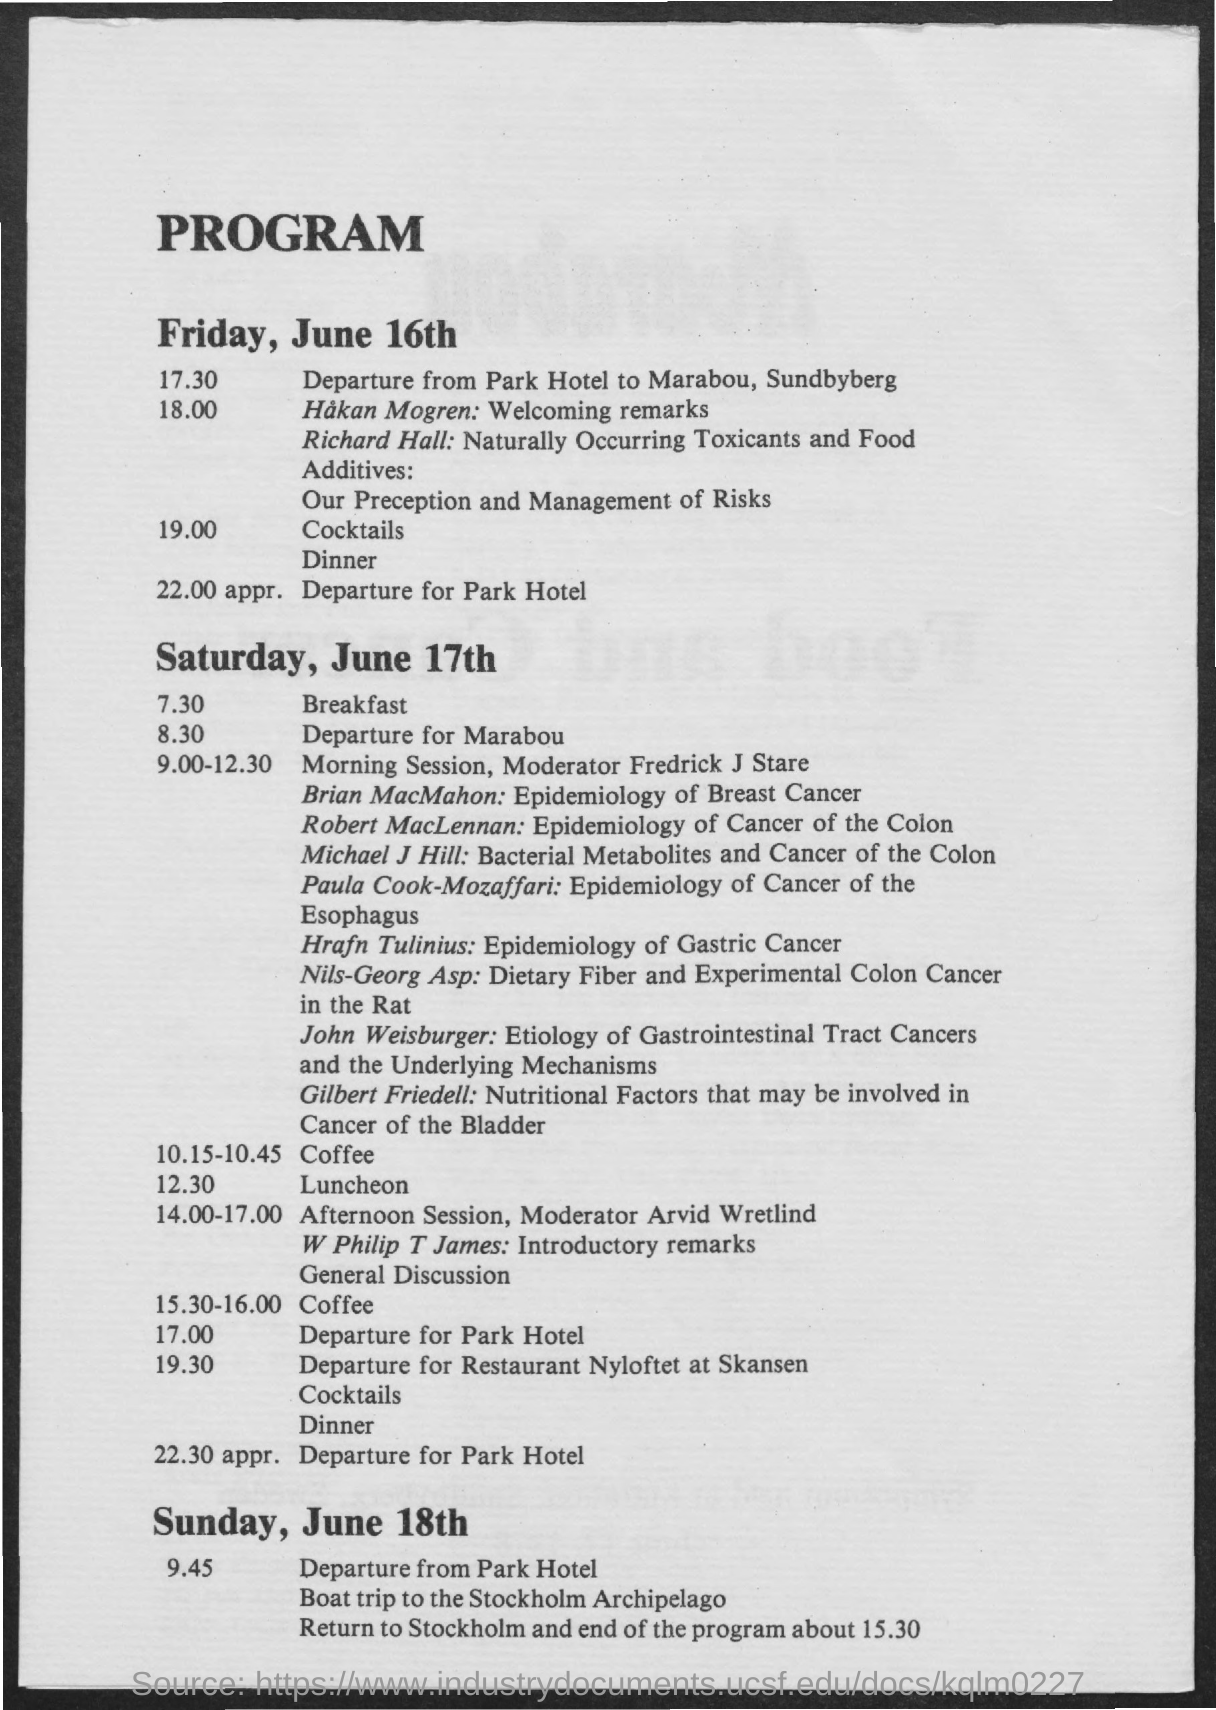Point out several critical features in this image. The speaker who delivered welcoming remarks was Hakan Mogren. The topic of Gilbert Friedell is nutritional factors that may be involved in cancer of the bladder. Brian MacMahon discussed the epidemiology of breast cancer. The first meeting will take place at Marabou, Sundbyberg. 